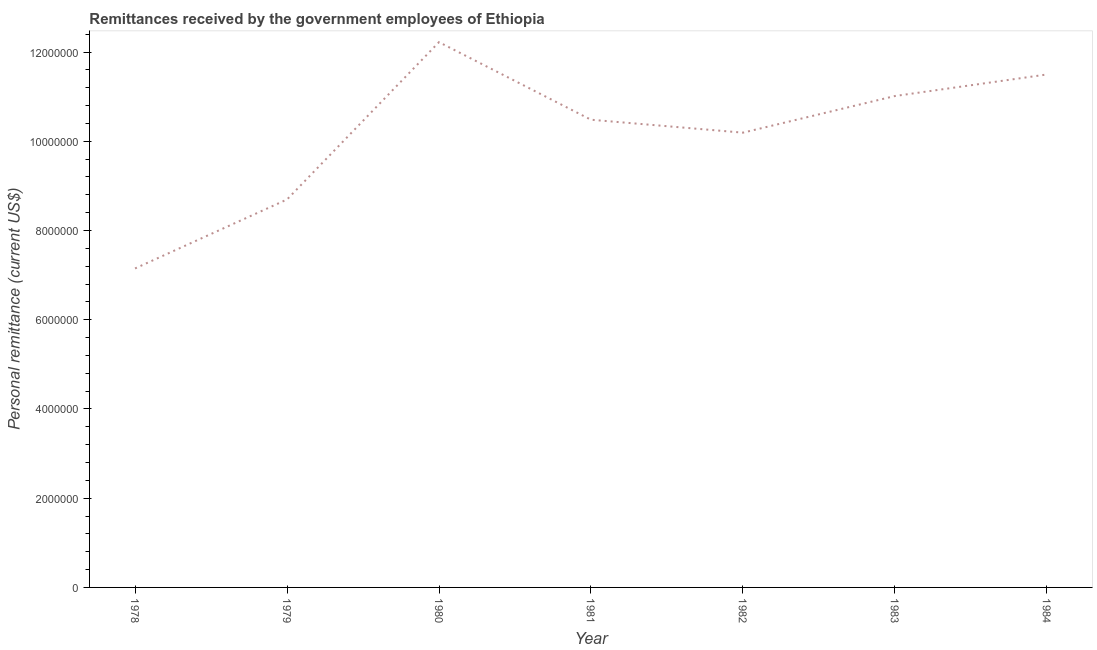What is the personal remittances in 1979?
Keep it short and to the point. 8.70e+06. Across all years, what is the maximum personal remittances?
Offer a very short reply. 1.22e+07. Across all years, what is the minimum personal remittances?
Offer a terse response. 7.15e+06. In which year was the personal remittances minimum?
Provide a succinct answer. 1978. What is the sum of the personal remittances?
Your response must be concise. 7.13e+07. What is the difference between the personal remittances in 1980 and 1981?
Make the answer very short. 1.74e+06. What is the average personal remittances per year?
Your response must be concise. 1.02e+07. What is the median personal remittances?
Your response must be concise. 1.05e+07. What is the ratio of the personal remittances in 1978 to that in 1979?
Make the answer very short. 0.82. Is the personal remittances in 1978 less than that in 1980?
Keep it short and to the point. Yes. What is the difference between the highest and the second highest personal remittances?
Give a very brief answer. 7.25e+05. Is the sum of the personal remittances in 1983 and 1984 greater than the maximum personal remittances across all years?
Offer a terse response. Yes. What is the difference between the highest and the lowest personal remittances?
Offer a very short reply. 5.07e+06. Does the personal remittances monotonically increase over the years?
Ensure brevity in your answer.  No. How many years are there in the graph?
Your answer should be very brief. 7. Does the graph contain grids?
Provide a succinct answer. No. What is the title of the graph?
Offer a very short reply. Remittances received by the government employees of Ethiopia. What is the label or title of the Y-axis?
Ensure brevity in your answer.  Personal remittance (current US$). What is the Personal remittance (current US$) in 1978?
Provide a succinct answer. 7.15e+06. What is the Personal remittance (current US$) in 1979?
Offer a very short reply. 8.70e+06. What is the Personal remittance (current US$) of 1980?
Give a very brief answer. 1.22e+07. What is the Personal remittance (current US$) of 1981?
Make the answer very short. 1.05e+07. What is the Personal remittance (current US$) in 1982?
Make the answer very short. 1.02e+07. What is the Personal remittance (current US$) of 1983?
Keep it short and to the point. 1.10e+07. What is the Personal remittance (current US$) in 1984?
Your response must be concise. 1.15e+07. What is the difference between the Personal remittance (current US$) in 1978 and 1979?
Provide a succinct answer. -1.55e+06. What is the difference between the Personal remittance (current US$) in 1978 and 1980?
Your answer should be very brief. -5.07e+06. What is the difference between the Personal remittance (current US$) in 1978 and 1981?
Your response must be concise. -3.33e+06. What is the difference between the Personal remittance (current US$) in 1978 and 1982?
Provide a short and direct response. -3.04e+06. What is the difference between the Personal remittance (current US$) in 1978 and 1983?
Offer a terse response. -3.86e+06. What is the difference between the Personal remittance (current US$) in 1978 and 1984?
Provide a succinct answer. -4.35e+06. What is the difference between the Personal remittance (current US$) in 1979 and 1980?
Keep it short and to the point. -3.53e+06. What is the difference between the Personal remittance (current US$) in 1979 and 1981?
Make the answer very short. -1.79e+06. What is the difference between the Personal remittance (current US$) in 1979 and 1982?
Provide a succinct answer. -1.50e+06. What is the difference between the Personal remittance (current US$) in 1979 and 1983?
Keep it short and to the point. -2.32e+06. What is the difference between the Personal remittance (current US$) in 1979 and 1984?
Your response must be concise. -2.80e+06. What is the difference between the Personal remittance (current US$) in 1980 and 1981?
Ensure brevity in your answer.  1.74e+06. What is the difference between the Personal remittance (current US$) in 1980 and 1982?
Ensure brevity in your answer.  2.03e+06. What is the difference between the Personal remittance (current US$) in 1980 and 1983?
Offer a terse response. 1.21e+06. What is the difference between the Personal remittance (current US$) in 1980 and 1984?
Your response must be concise. 7.25e+05. What is the difference between the Personal remittance (current US$) in 1981 and 1982?
Make the answer very short. 2.90e+05. What is the difference between the Personal remittance (current US$) in 1981 and 1983?
Ensure brevity in your answer.  -5.31e+05. What is the difference between the Personal remittance (current US$) in 1981 and 1984?
Your answer should be very brief. -1.01e+06. What is the difference between the Personal remittance (current US$) in 1982 and 1983?
Provide a succinct answer. -8.21e+05. What is the difference between the Personal remittance (current US$) in 1982 and 1984?
Provide a succinct answer. -1.30e+06. What is the difference between the Personal remittance (current US$) in 1983 and 1984?
Provide a succinct answer. -4.83e+05. What is the ratio of the Personal remittance (current US$) in 1978 to that in 1979?
Provide a succinct answer. 0.82. What is the ratio of the Personal remittance (current US$) in 1978 to that in 1980?
Offer a very short reply. 0.58. What is the ratio of the Personal remittance (current US$) in 1978 to that in 1981?
Your answer should be very brief. 0.68. What is the ratio of the Personal remittance (current US$) in 1978 to that in 1982?
Give a very brief answer. 0.7. What is the ratio of the Personal remittance (current US$) in 1978 to that in 1983?
Your answer should be compact. 0.65. What is the ratio of the Personal remittance (current US$) in 1978 to that in 1984?
Provide a short and direct response. 0.62. What is the ratio of the Personal remittance (current US$) in 1979 to that in 1980?
Keep it short and to the point. 0.71. What is the ratio of the Personal remittance (current US$) in 1979 to that in 1981?
Provide a short and direct response. 0.83. What is the ratio of the Personal remittance (current US$) in 1979 to that in 1982?
Offer a very short reply. 0.85. What is the ratio of the Personal remittance (current US$) in 1979 to that in 1983?
Your answer should be very brief. 0.79. What is the ratio of the Personal remittance (current US$) in 1979 to that in 1984?
Offer a terse response. 0.76. What is the ratio of the Personal remittance (current US$) in 1980 to that in 1981?
Provide a succinct answer. 1.17. What is the ratio of the Personal remittance (current US$) in 1980 to that in 1982?
Your response must be concise. 1.2. What is the ratio of the Personal remittance (current US$) in 1980 to that in 1983?
Offer a terse response. 1.11. What is the ratio of the Personal remittance (current US$) in 1980 to that in 1984?
Offer a terse response. 1.06. What is the ratio of the Personal remittance (current US$) in 1981 to that in 1982?
Offer a terse response. 1.03. What is the ratio of the Personal remittance (current US$) in 1981 to that in 1984?
Ensure brevity in your answer.  0.91. What is the ratio of the Personal remittance (current US$) in 1982 to that in 1983?
Keep it short and to the point. 0.93. What is the ratio of the Personal remittance (current US$) in 1982 to that in 1984?
Your answer should be very brief. 0.89. What is the ratio of the Personal remittance (current US$) in 1983 to that in 1984?
Your answer should be compact. 0.96. 